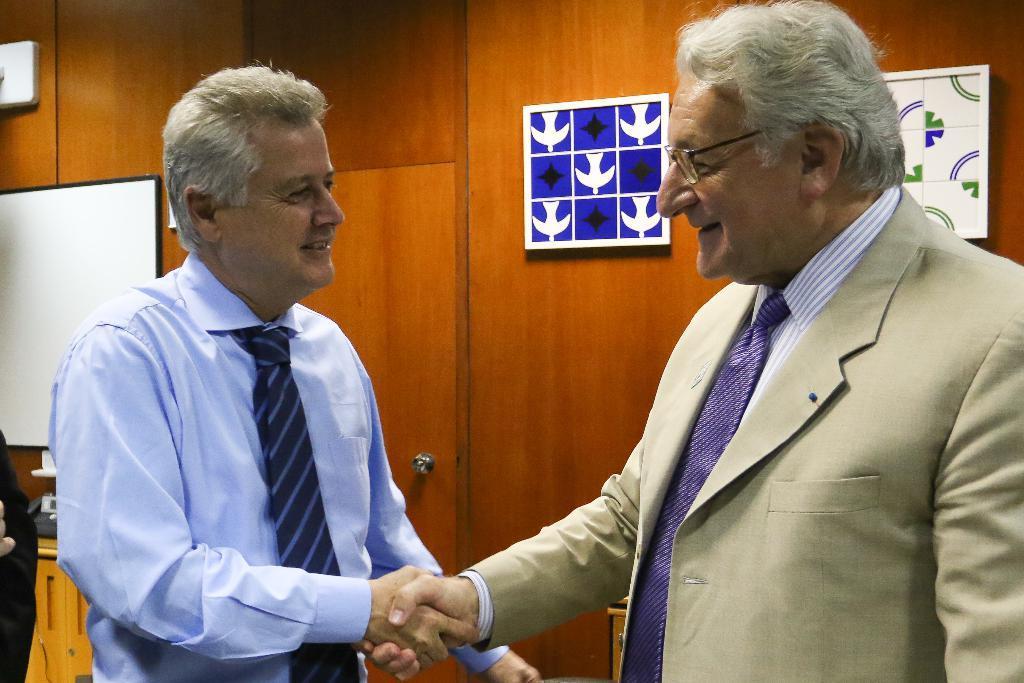Describe this image in one or two sentences. In the picture I can see two men shaking the hands and there is a smile on their face. The man on the right side is wearing a suit and tie. I can see another man on the left side is wearing a shirt and tie. I can see the wooden door with handle. I can see a white board on the wooden wall on the left side. I can see the decorative design objects on the wall on the right side. 